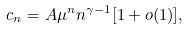Convert formula to latex. <formula><loc_0><loc_0><loc_500><loc_500>c _ { n } = A \mu ^ { n } n ^ { \gamma - 1 } [ 1 + o ( 1 ) ] ,</formula> 